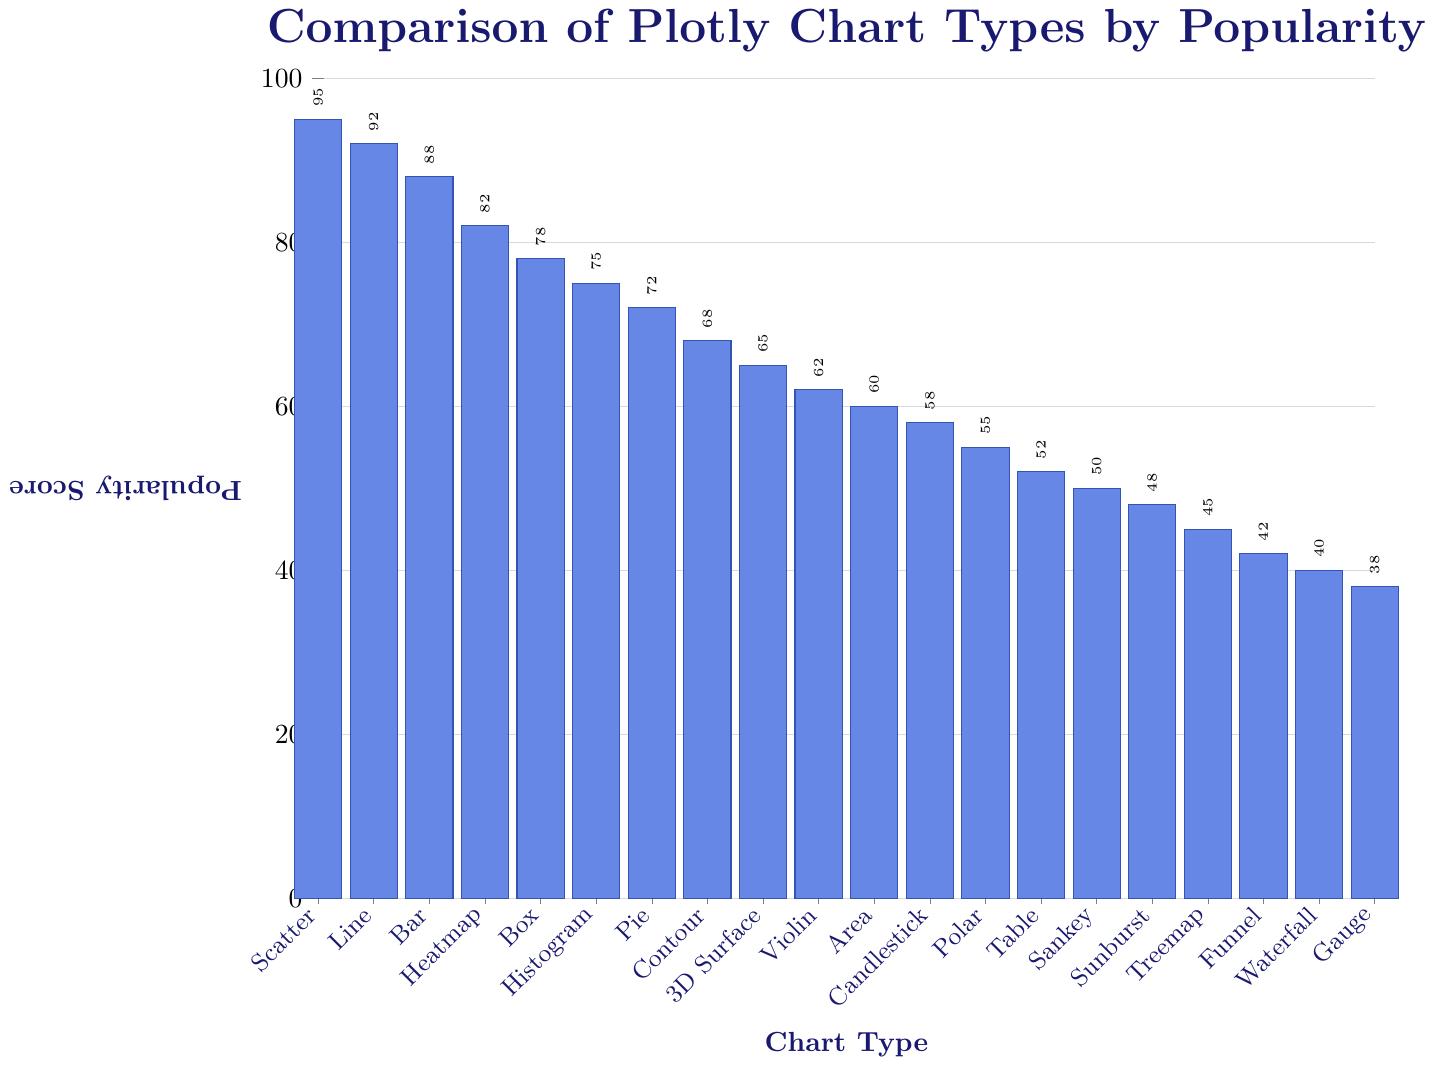Which chart type is the most popular according to the figure? By observing the heights of the bars, the chart type with the highest bar corresponds to the highest popularity score. The tallest bar represents the Scatter chart with a score of 95.
Answer: Scatter What is the difference in popularity scores between the Scatter and Polar chart types? The popularity score for Scatter is 95 and for Polar is 55. The difference can be calculated as 95 - 55.
Answer: 40 Which chart type has a score closest to 60? By looking at the y-axis and comparing the heights of the bars, we find that the Area chart has a popularity score of 60.
Answer: Area What is the average popularity score for the top three chart types? The top three chart types are Scatter (95), Line (92), and Bar (88). Summing these scores: 95 + 92 + 88 = 275. Dividing by 3, the average is 275 / 3.
Answer: 91.67 How many chart types have a popularity score lower than 50? Observing the bars on the chart, the chart types with scores lower than 50 are Sunburst (48), Treemap (45), Funnel (42), Waterfall (40), and Gauge (38). That totals 5 chart types.
Answer: 5 Which chart type has a lower popularity score, Table or Violin? By comparing the heights of the bars, Table has a score of 52 and Violin has a score of 62. Since 52 < 62, Table has the lower score.
Answer: Table What is the combined popularity score of the Heatmap, Pie, and Contour chart types? The popularity scores are Heatmap (82), Pie (72), and Contour (68). Summing them: 82 + 72 + 68.
Answer: 222 Which chart types have popularity scores between 70 and 80? Observing the height of the bars that fall between 70 and 80 on the y-axis, the relevant chart types are Pie (72) and Histogram (75).
Answer: Pie, Histogram How does the popularity of the Candlestick chart compare to the Violin chart? By looking at the heights of the bars, Candlestick has a score of 58 and Violin has a score of 62. Since 58 < 62, the Candlestick chart is less popular than the Violin chart.
Answer: Less popular Is the Sankey chart more popular than the Sunburst chart? The Sankey chart has a popularity score of 50, while the Sunburst chart has a score of 48. Since 50 > 48, the Sankey chart is more popular.
Answer: Yes 